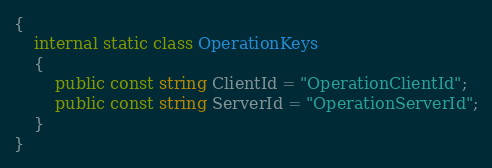<code> <loc_0><loc_0><loc_500><loc_500><_C#_>{
    internal static class OperationKeys
    {
        public const string ClientId = "OperationClientId";
        public const string ServerId = "OperationServerId";
    }
}</code> 